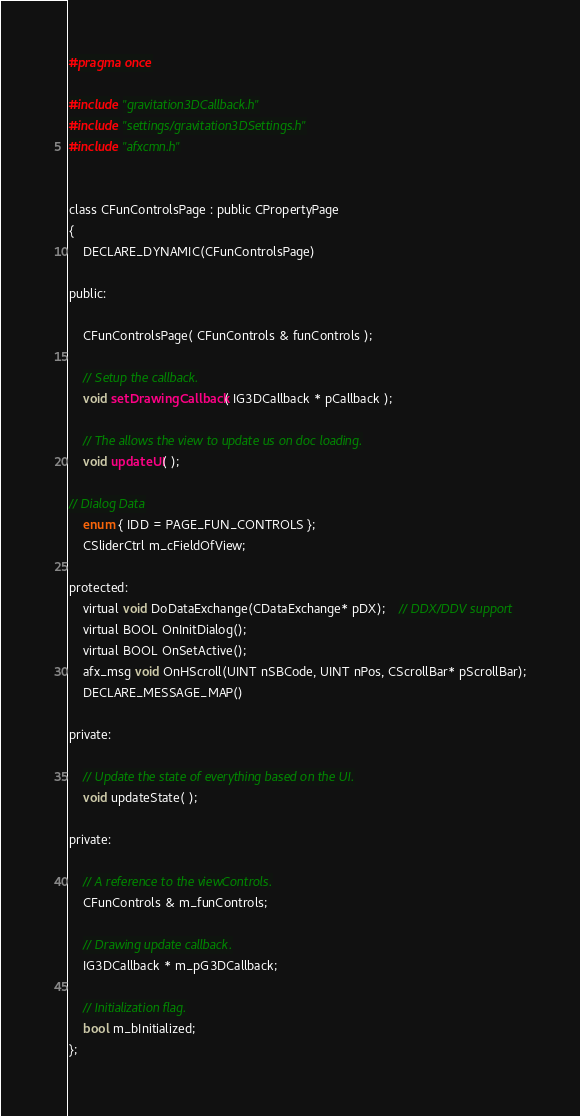<code> <loc_0><loc_0><loc_500><loc_500><_C_>#pragma once

#include "gravitation3DCallback.h"
#include "settings/gravitation3DSettings.h"
#include "afxcmn.h"


class CFunControlsPage : public CPropertyPage
{
	DECLARE_DYNAMIC(CFunControlsPage)

public:

	CFunControlsPage( CFunControls & funControls );

	// Setup the callback.
	void setDrawingCallback( IG3DCallback * pCallback );

	// The allows the view to update us on doc loading.
	void updateUI( );

// Dialog Data
	enum { IDD = PAGE_FUN_CONTROLS };
	CSliderCtrl m_cFieldOfView;

protected:
	virtual void DoDataExchange(CDataExchange* pDX);    // DDX/DDV support
	virtual BOOL OnInitDialog();
	virtual BOOL OnSetActive();
	afx_msg void OnHScroll(UINT nSBCode, UINT nPos, CScrollBar* pScrollBar);
	DECLARE_MESSAGE_MAP()

private:

	// Update the state of everything based on the UI.
	void updateState( );

private:

	// A reference to the viewControls.
	CFunControls & m_funControls;

	// Drawing update callback.
	IG3DCallback * m_pG3DCallback;

	// Initialization flag.
	bool m_bInitialized;
};
</code> 